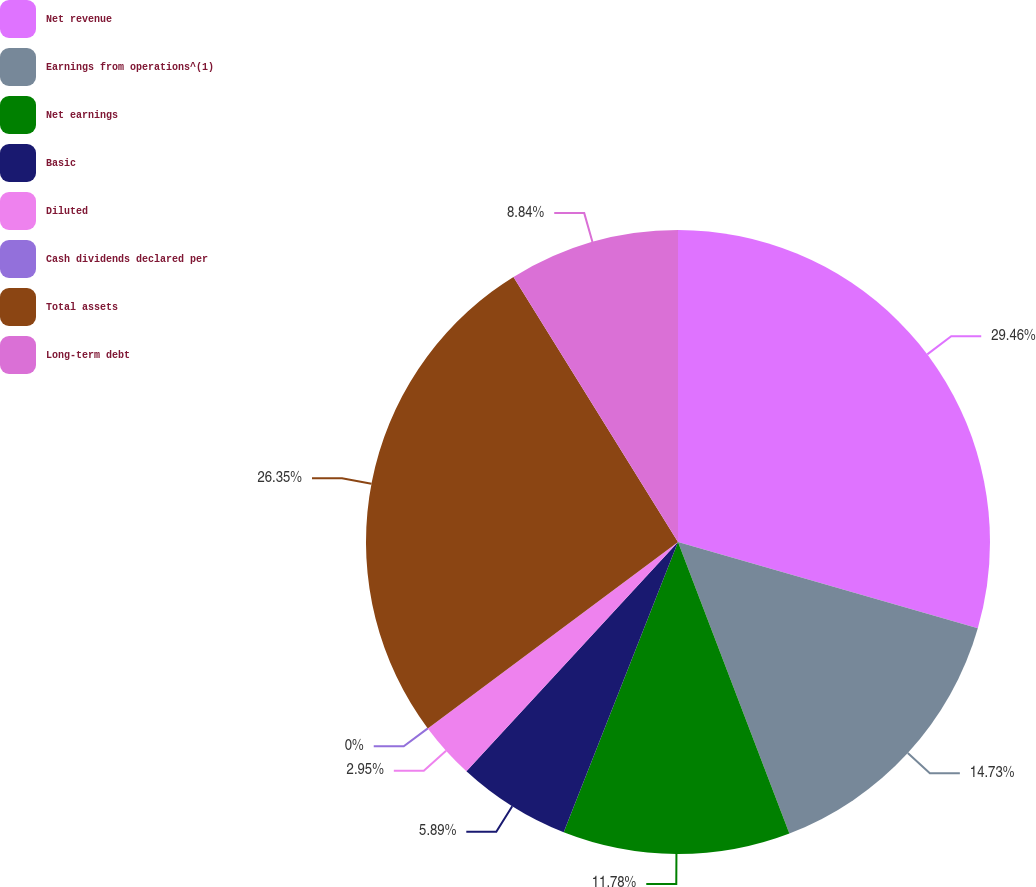Convert chart. <chart><loc_0><loc_0><loc_500><loc_500><pie_chart><fcel>Net revenue<fcel>Earnings from operations^(1)<fcel>Net earnings<fcel>Basic<fcel>Diluted<fcel>Cash dividends declared per<fcel>Total assets<fcel>Long-term debt<nl><fcel>29.46%<fcel>14.73%<fcel>11.78%<fcel>5.89%<fcel>2.95%<fcel>0.0%<fcel>26.35%<fcel>8.84%<nl></chart> 